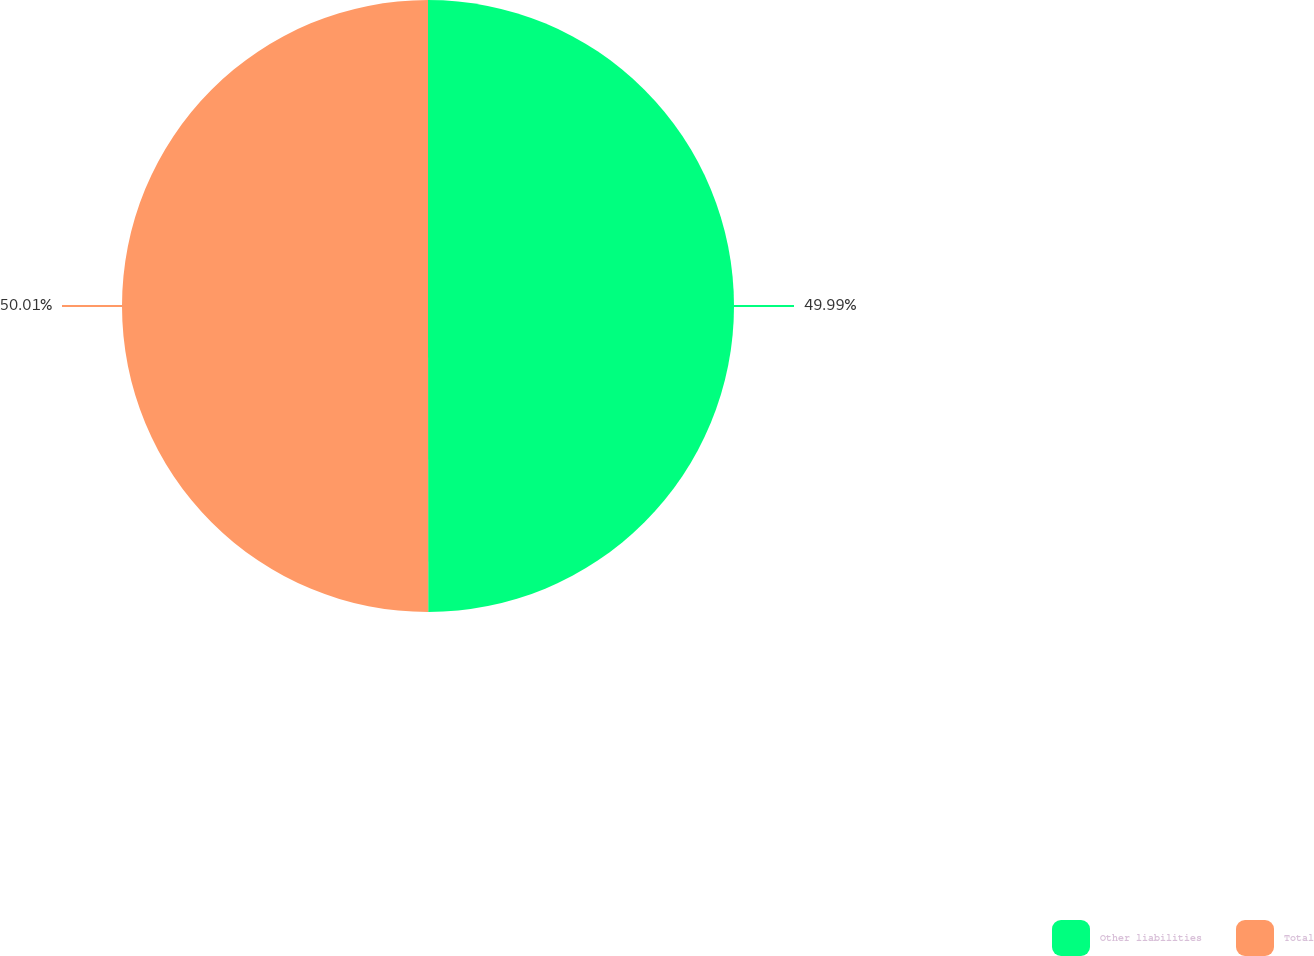Convert chart. <chart><loc_0><loc_0><loc_500><loc_500><pie_chart><fcel>Other liabilities<fcel>Total<nl><fcel>49.99%<fcel>50.01%<nl></chart> 